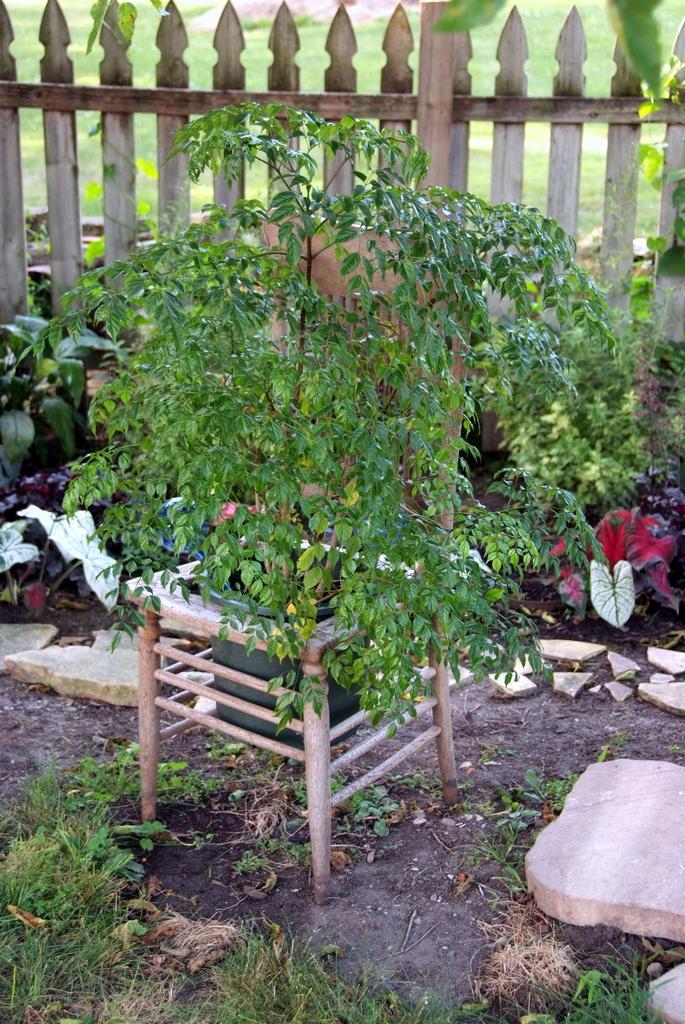Please provide a concise description of this image. In the middle of this image, there is a potted plant attached to a chair which is on the ground, on which there are stones and grass. In the background, there is a fence. Besides this fence, there are plants on the ground. Outside this fence, there's grass on the ground. 